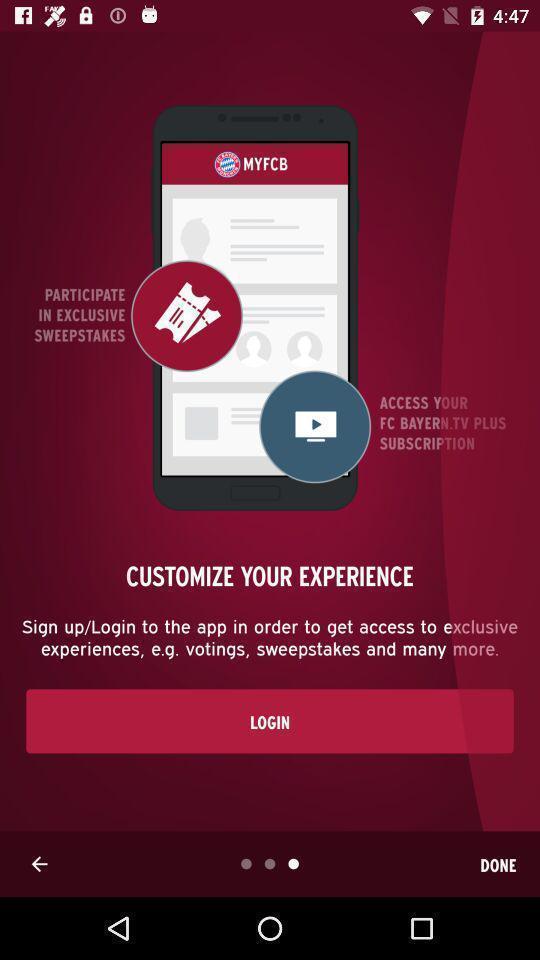Give me a narrative description of this picture. Login page with done option. 